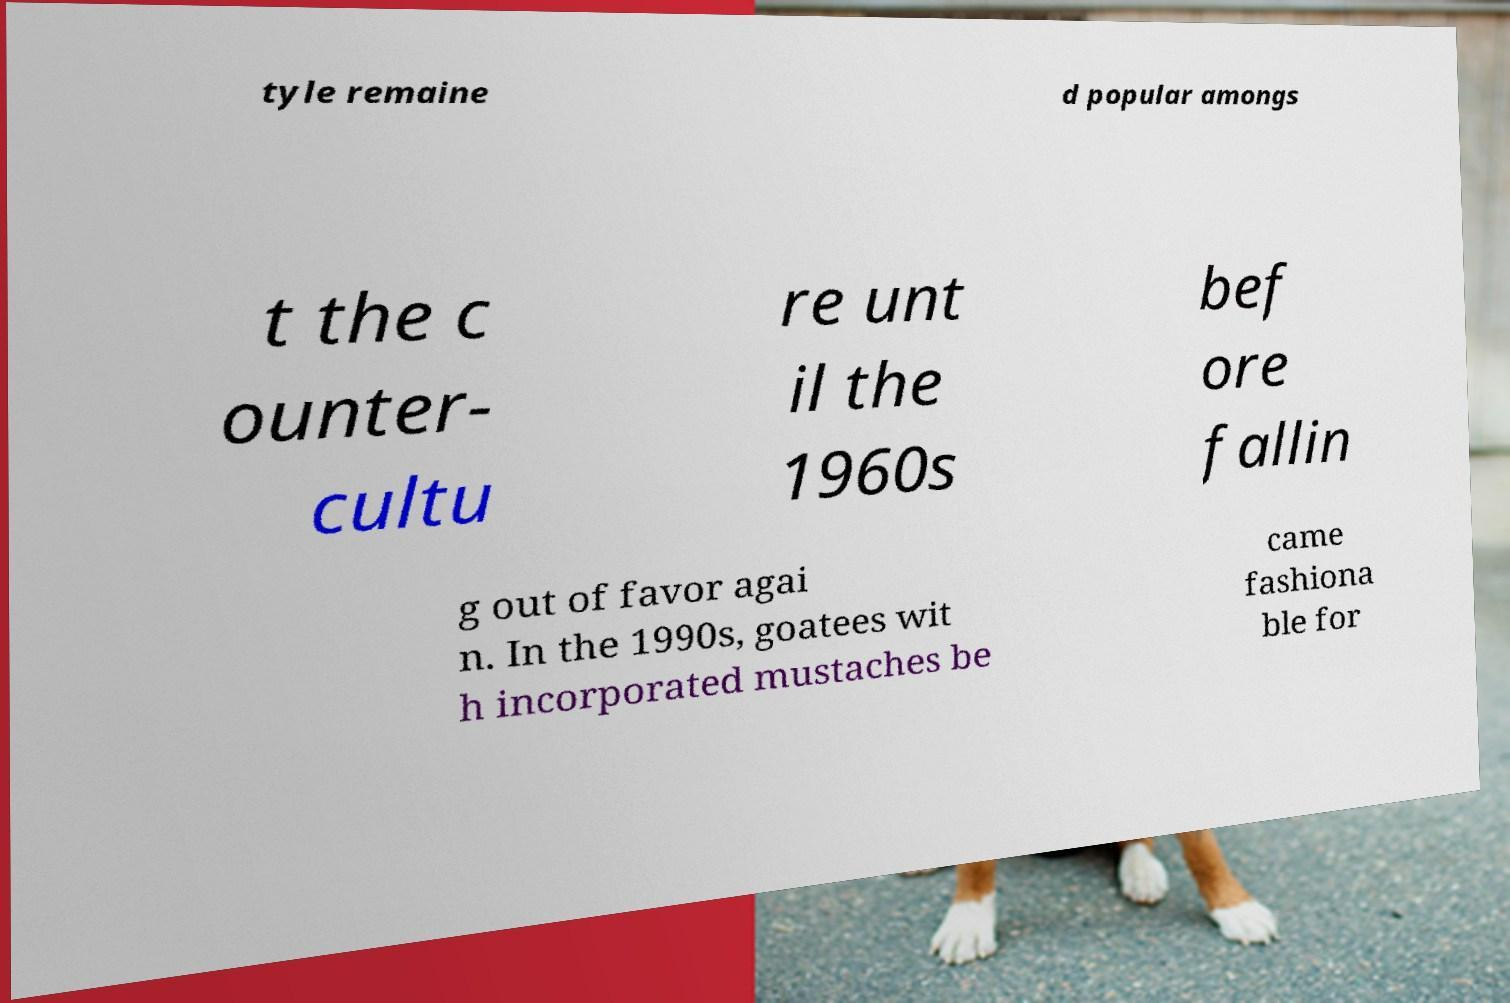For documentation purposes, I need the text within this image transcribed. Could you provide that? tyle remaine d popular amongs t the c ounter- cultu re unt il the 1960s bef ore fallin g out of favor agai n. In the 1990s, goatees wit h incorporated mustaches be came fashiona ble for 